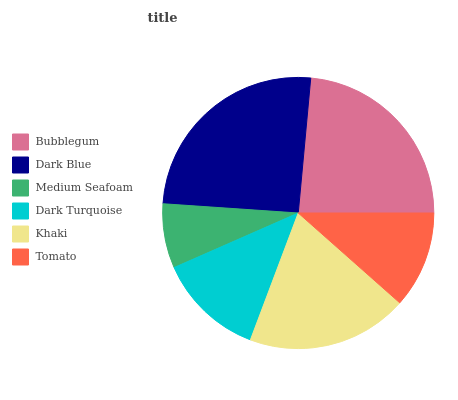Is Medium Seafoam the minimum?
Answer yes or no. Yes. Is Dark Blue the maximum?
Answer yes or no. Yes. Is Dark Blue the minimum?
Answer yes or no. No. Is Medium Seafoam the maximum?
Answer yes or no. No. Is Dark Blue greater than Medium Seafoam?
Answer yes or no. Yes. Is Medium Seafoam less than Dark Blue?
Answer yes or no. Yes. Is Medium Seafoam greater than Dark Blue?
Answer yes or no. No. Is Dark Blue less than Medium Seafoam?
Answer yes or no. No. Is Khaki the high median?
Answer yes or no. Yes. Is Dark Turquoise the low median?
Answer yes or no. Yes. Is Dark Turquoise the high median?
Answer yes or no. No. Is Dark Blue the low median?
Answer yes or no. No. 